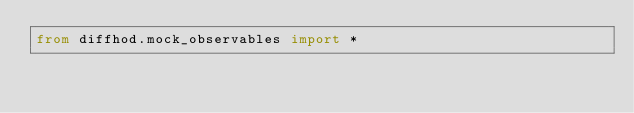<code> <loc_0><loc_0><loc_500><loc_500><_Python_>from diffhod.mock_observables import *
</code> 